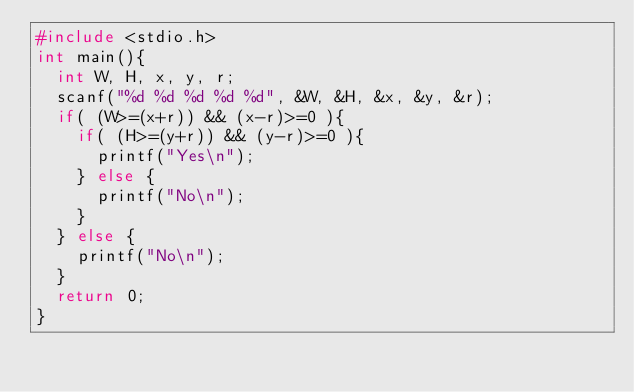Convert code to text. <code><loc_0><loc_0><loc_500><loc_500><_C_>#include <stdio.h>
int main(){
	int W, H, x, y, r;
	scanf("%d %d %d %d %d", &W, &H, &x, &y, &r);
	if( (W>=(x+r)) && (x-r)>=0 ){
		if( (H>=(y+r)) && (y-r)>=0 ){
			printf("Yes\n");
		} else {
			printf("No\n");
		}
	} else {
		printf("No\n");
	}
	return 0;
}</code> 